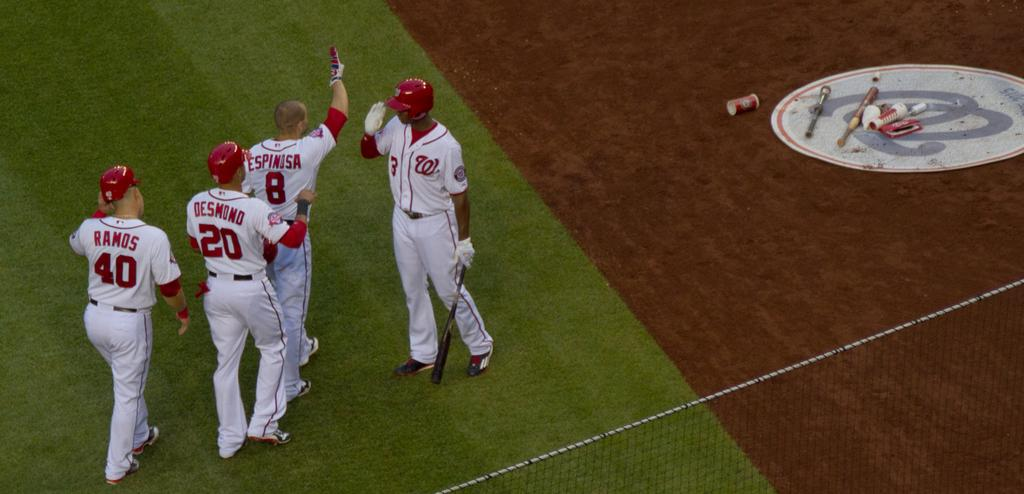<image>
Summarize the visual content of the image. Baseball player Espinosa is about to high five the batter while two other teammates walk behind him. 